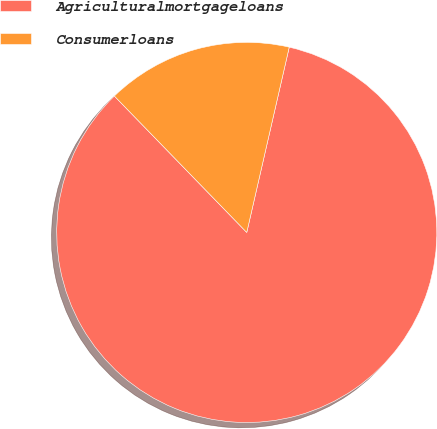Convert chart to OTSL. <chart><loc_0><loc_0><loc_500><loc_500><pie_chart><fcel>Agriculturalmortgageloans<fcel>Consumerloans<nl><fcel>84.15%<fcel>15.85%<nl></chart> 